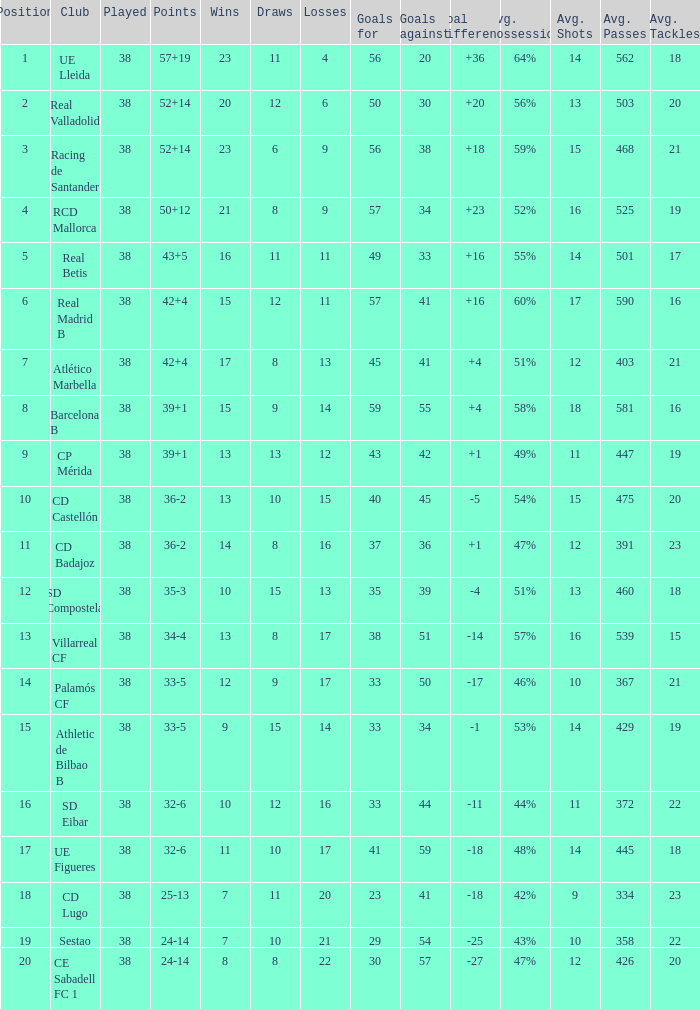What is the highest number of loss with a 7 position and more than 45 goals? None. 